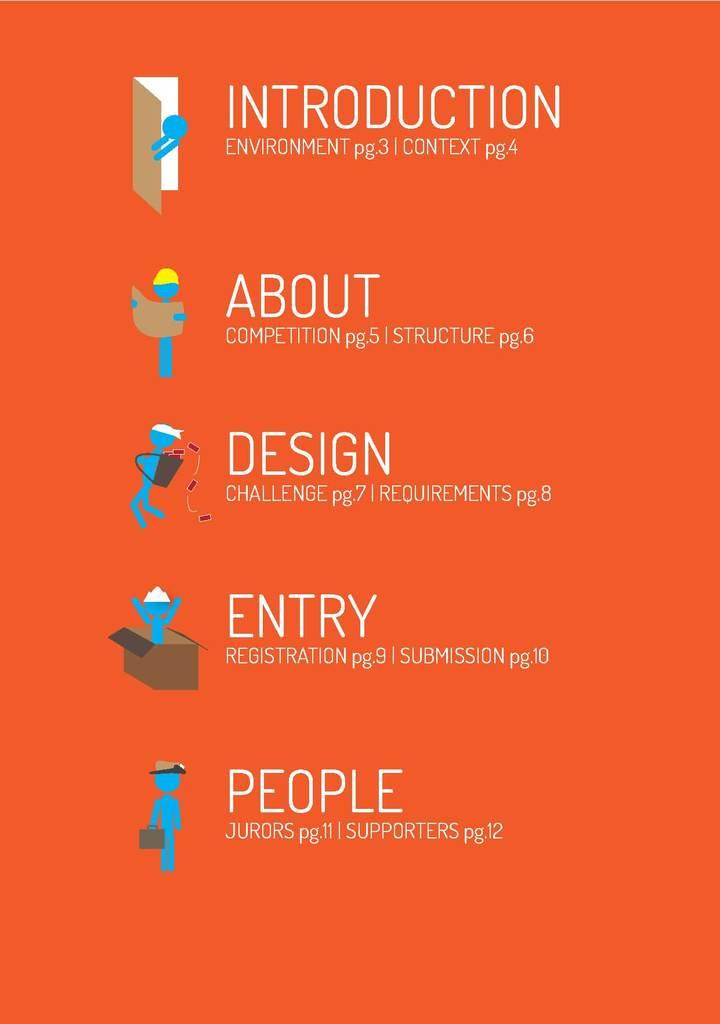Is that a book content?
Your response must be concise. Yes. What is the bottom word on the page?
Provide a short and direct response. People. 